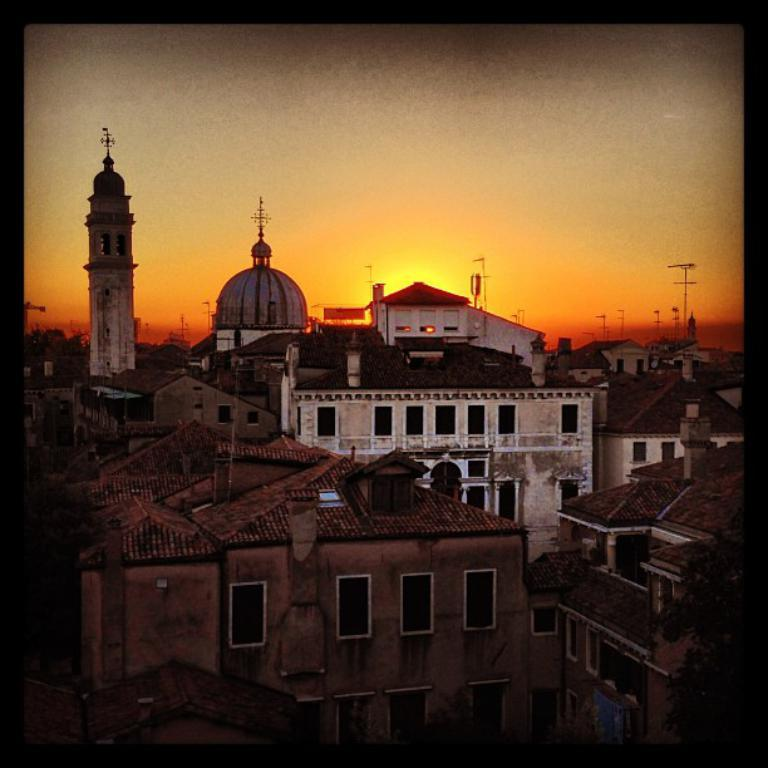What type of structures are present in the image? There are many buildings in the image. Are the buildings located in a specific environment? The buildings are on land. What else can be seen in the image besides the buildings? The sky is visible in the image. Can you describe the time of day when the image was taken? The image was taken at dawn time. What type of oil can be seen dripping from the buildings in the image? There is no oil present in the image; it features buildings on land with the sky visible. 